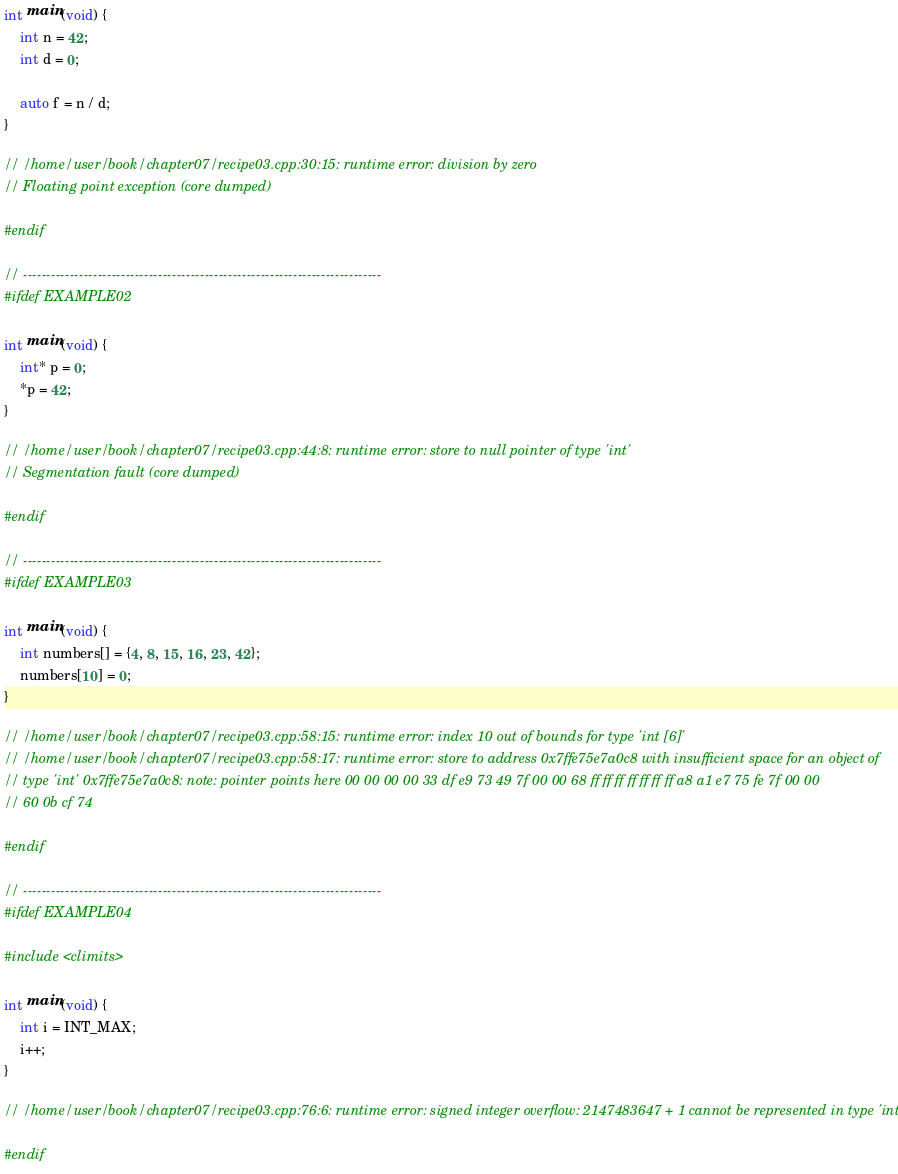Convert code to text. <code><loc_0><loc_0><loc_500><loc_500><_C++_>
int main(void) {
    int n = 42;
    int d = 0;

    auto f = n / d;
}

// /home/user/book/chapter07/recipe03.cpp:30:15: runtime error: division by zero
// Floating point exception (core dumped)

#endif

// -----------------------------------------------------------------------------
#ifdef EXAMPLE02

int main(void) {
    int* p = 0;
    *p = 42;
}

// /home/user/book/chapter07/recipe03.cpp:44:8: runtime error: store to null pointer of type 'int'
// Segmentation fault (core dumped)

#endif

// -----------------------------------------------------------------------------
#ifdef EXAMPLE03

int main(void) {
    int numbers[] = {4, 8, 15, 16, 23, 42};
    numbers[10] = 0;
}

// /home/user/book/chapter07/recipe03.cpp:58:15: runtime error: index 10 out of bounds for type 'int [6]'
// /home/user/book/chapter07/recipe03.cpp:58:17: runtime error: store to address 0x7ffe75e7a0c8 with insufficient space for an object of
// type 'int' 0x7ffe75e7a0c8: note: pointer points here 00 00 00 00 33 df e9 73 49 7f 00 00 68 ff ff ff ff ff ff ff a8 a1 e7 75 fe 7f 00 00
// 60 0b cf 74

#endif

// -----------------------------------------------------------------------------
#ifdef EXAMPLE04

#include <climits>

int main(void) {
    int i = INT_MAX;
    i++;
}

// /home/user/book/chapter07/recipe03.cpp:76:6: runtime error: signed integer overflow: 2147483647 + 1 cannot be represented in type 'int'

#endif
</code> 